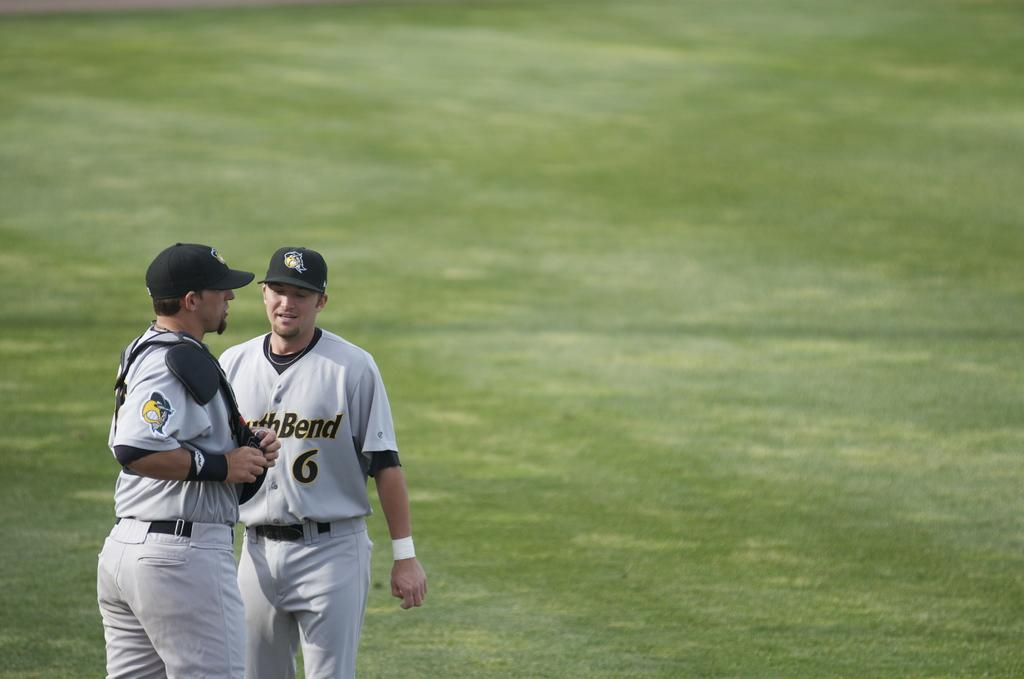How many people are in the image? There are two persons in the image. What color are the dresses worn by the persons? Both persons are wearing white color dresses. What color are the caps worn by the persons? Both persons are wearing black color caps. Where are the persons standing in the image? The persons are standing on the ground. What type of vegetation can be seen in the image? There is a lawn visible in the image. Reasoning: Let'ing: Let's think step by step in order to produce the conversation. We start by identifying the number of persons in the image, which is two. Then, we describe the colors of their dresses and caps to provide more details about their appearance. Next, we mention their location, which is standing on the ground. Finally, we identify the type of vegetation present in the image, which is a lawn. Absurd Question/Answer: What type of bag is the actor carrying in the image? There is no actor or bag present in the image. The image features two persons wearing white dresses and black caps, standing on the ground with a lawn visible in the background. 